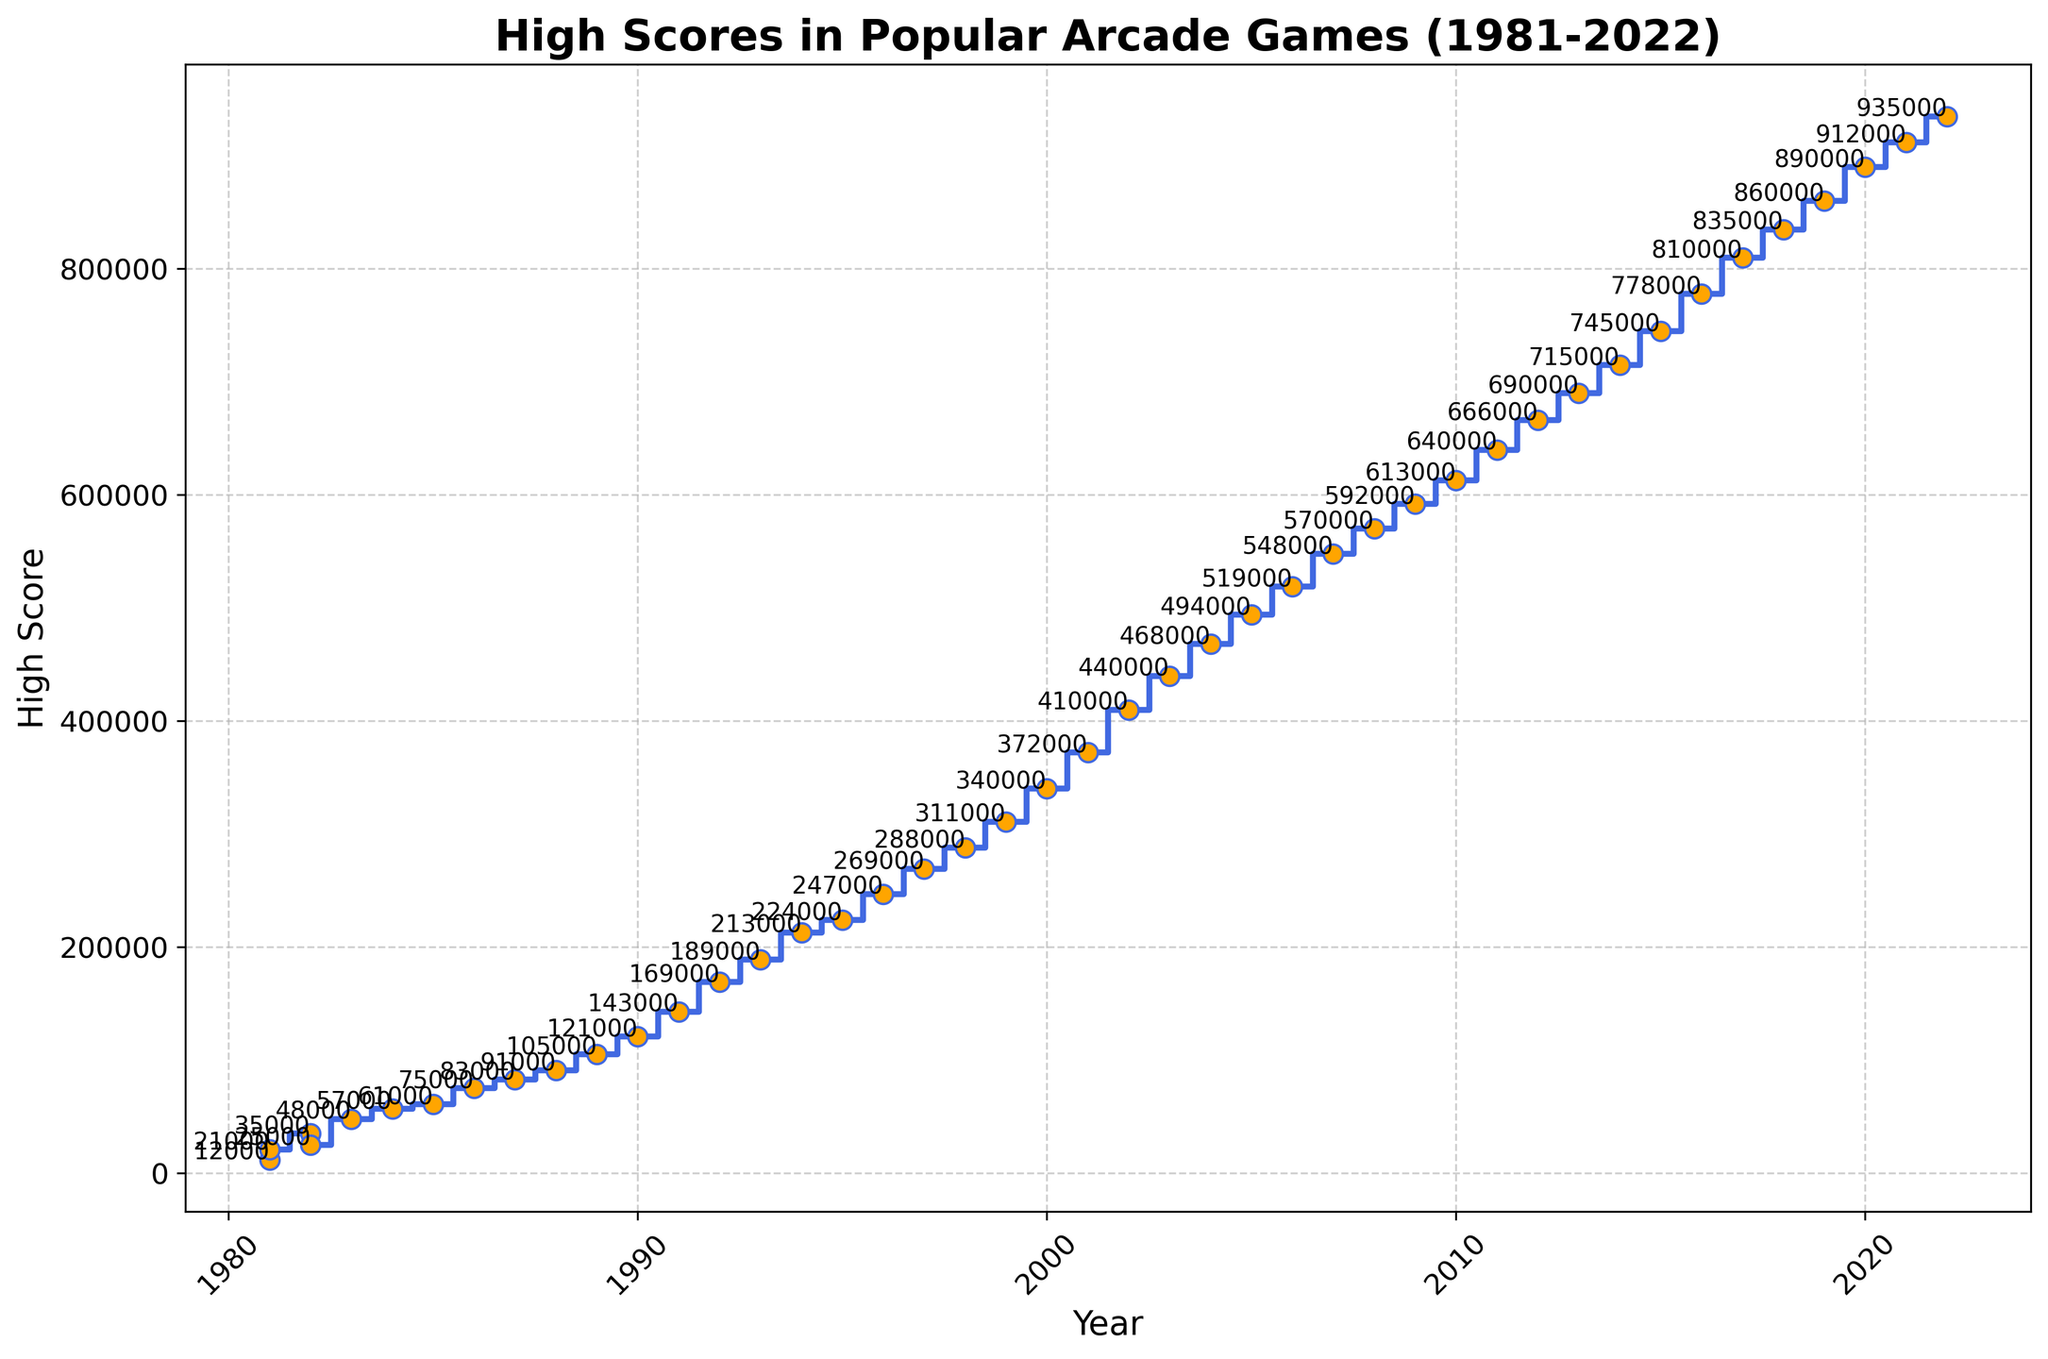Which year had the highest score and what was it? The highest score appears at the rightmost end of the plot in 2022. By looking at the year and the corresponding score, we can see that 2022 had the highest score of 935000.
Answer: 2022, 935000 What is the difference between the high scores in 1981 and 2022? Locate the scores for 1981 and 2022 on the x-axis (year) and find the corresponding y-values (scores). For 1981, the score was 21000 (Defender) and for 2022, it was 935000 (Fast & Furious Arcade). Subtract the two values: 935000 - 21000 = 914000.
Answer: 914000 What is the average high score for the years 1995, 2000, and 2005? Find the scores for the years 1995 (224000 for Time Crisis), 2000 (340000 for Marvel vs. Capcom 2), and 2005 (494000 for Ghost Squad). Add these values and divide by 3: (224000 + 340000 + 494000) / 3 = 358000.
Answer: 358000 Are the high scores increasing, decreasing, or inconsistent over time? Observing the overall trend from the left (1981) to the right (2022) of the plot, the high scores generally increase over time. This pattern indicates an increasing trend.
Answer: Increasing What was the score in 1995, and which game achieved it? Locate the year 1995 on the x-axis and find the corresponding high score on the y-axis. In 1995, the score was 224000. The game associated with this score is Time Crisis.
Answer: 224000, Time Crisis Compare the high scores between 1983 and 1993. Which year had a higher score and by how much? Find the high scores for 1983 (48000 for Dragon's Lair) and 1993 (189000 for Samurai Shodown). Subtract the 1983 score from the 1993 score: 189000 - 48000 = 141000. Therefore, 1993 had a higher score by 141000.
Answer: 1993, 141000 How many games had a score of over 500000 points? Look at the y-axis to identify the threshold level of 500000 points. Count the number of data points above this threshold: 7 games had scores over 500000 points (from 2006 onwards).
Answer: 7 What is the median high score for the years listed in the plot? To find the median, first, list all the high scores in ascending order. The median is the middle value in this list. There are 42 scores, so the median will be the average of the 21st and 22nd values: (247000+269000)/2 = 258000.
Answer: 258000 Which game had the highest increase in high score compared to the previous year, and how much was the increase? By examining each yearly increase, the highest jump is between 2001 (372000 for Initial D Arcade Stage) and 2002 (410000 for Time Crisis 3). The increase is 410000 - 372000 = 38000.
Answer: Time Crisis 3, 38000 What is the high score in 2018, and which game achieved it? Locate the year 2018 on the x-axis and find the corresponding high score on the y-axis. In 2018, the score was 835000. The game associated with this score is Namco Classic Collection.
Answer: 835000, Namco Classic Collection 